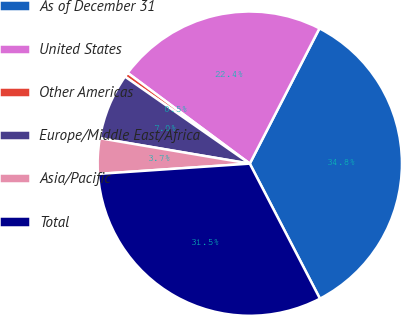Convert chart. <chart><loc_0><loc_0><loc_500><loc_500><pie_chart><fcel>As of December 31<fcel>United States<fcel>Other Americas<fcel>Europe/Middle East/Africa<fcel>Asia/Pacific<fcel>Total<nl><fcel>34.81%<fcel>22.4%<fcel>0.48%<fcel>7.02%<fcel>3.75%<fcel>31.55%<nl></chart> 